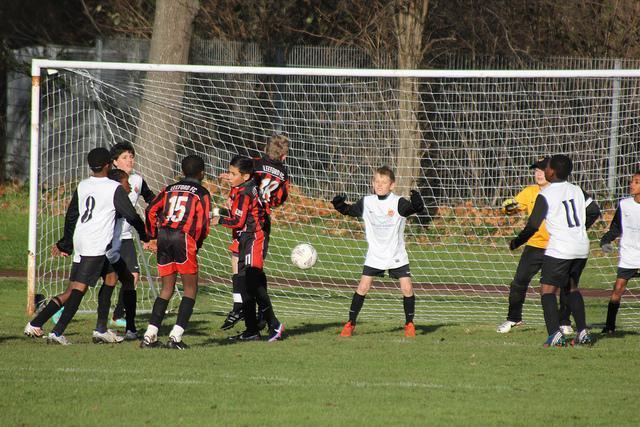How many kids are wearing black and white?
Give a very brief answer. 5. How many people are visible?
Give a very brief answer. 9. 